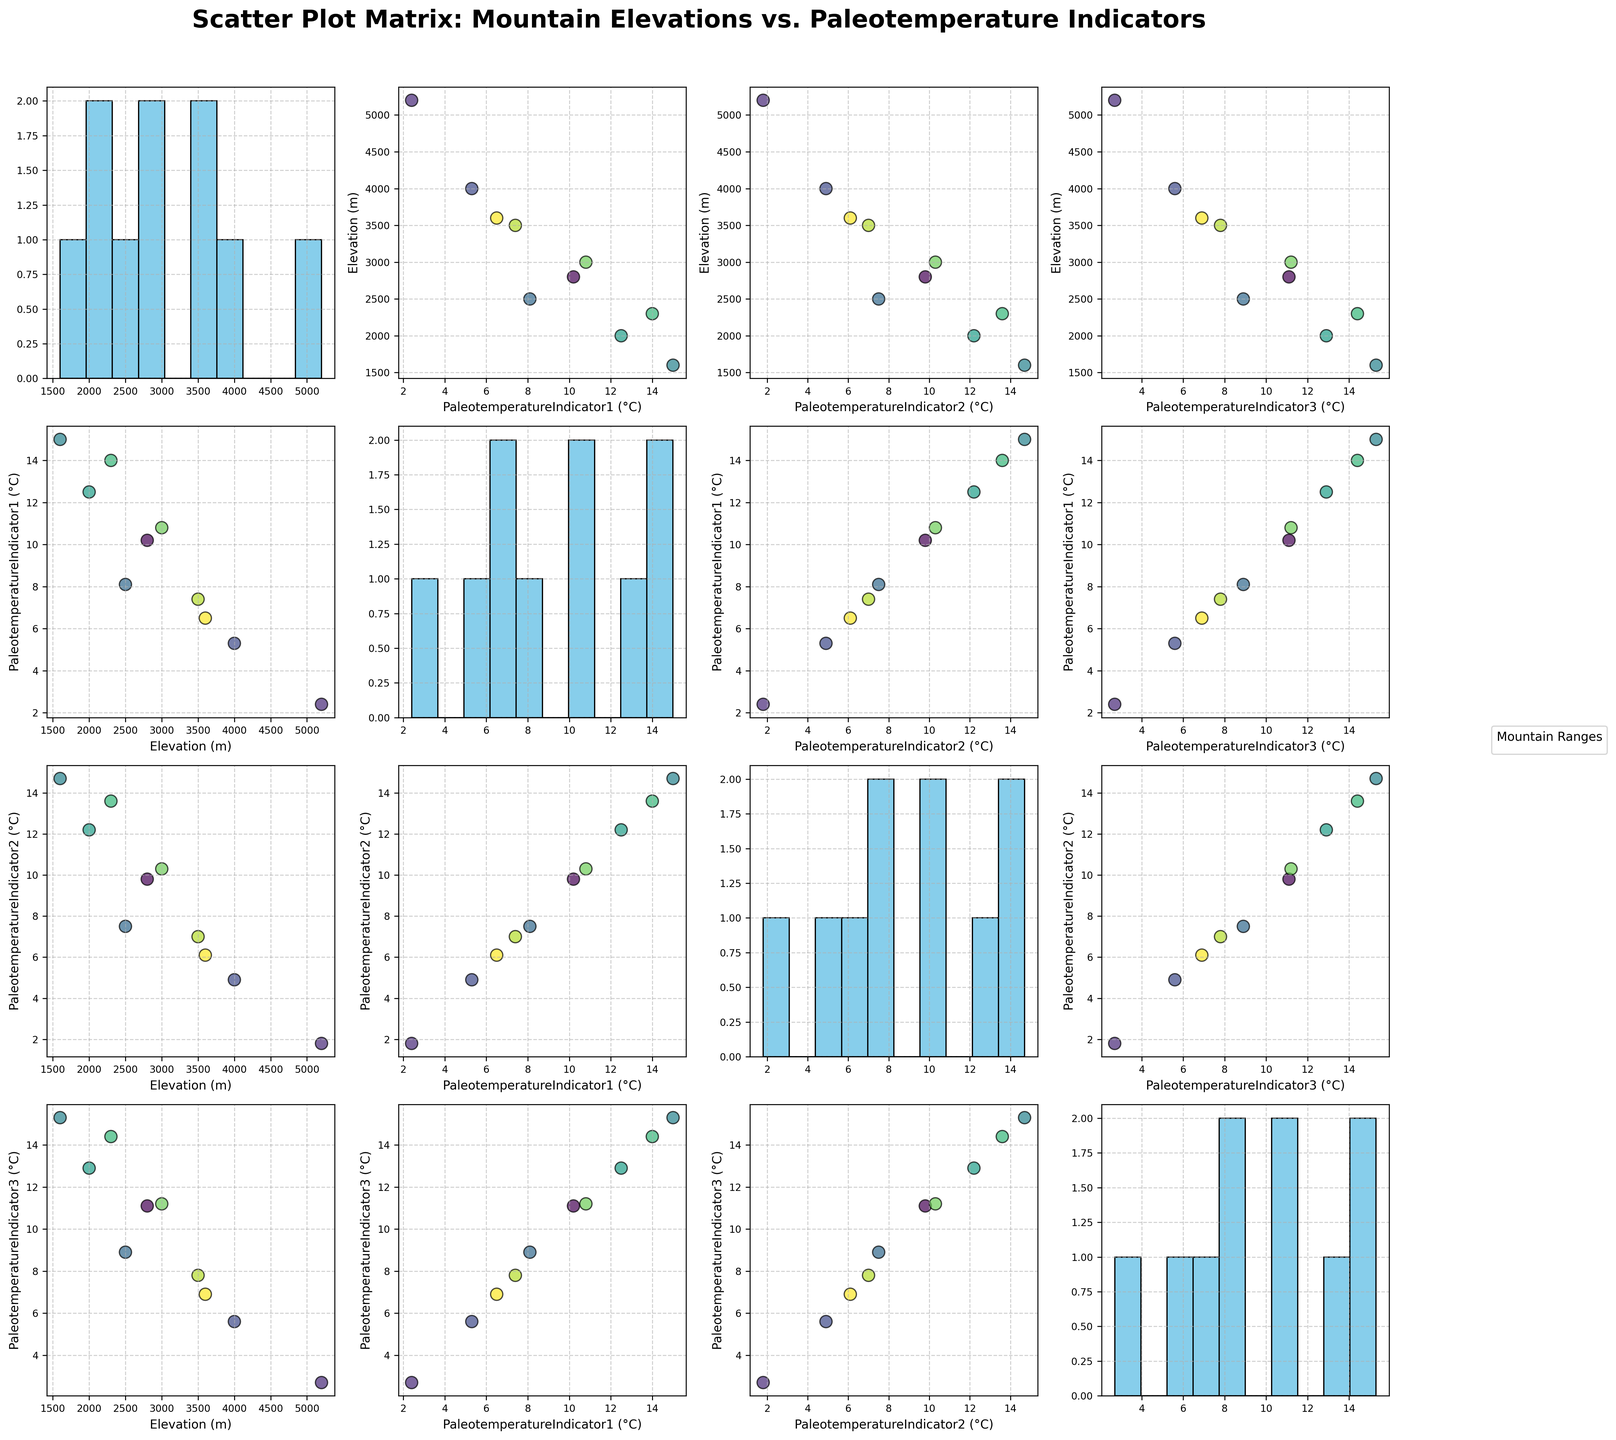What's the title of the scatter plot matrix? The title of the figure is located at the top-center and provides the overall description of the plot.
Answer: Scatter Plot Matrix: Mountain Elevations vs. Paleotemperature Indicators How many data points represent the Andes in the scatter plots? Each mountain range has a single data point in each scatter plot cell. There are 4 main variables (Elevation and 3 Paleotemperature Indicators), so each of the 4x4 scatter plot subplots features one point for Andes.
Answer: 1 Which Paleotemperature Indicator shows a stronger relationship with elevation - Indicator 1 or Indicator 2? By visually comparing the scatter plot subplots of 'Elevation (m)' with 'PaleotemperatureIndicator1 (°C)' and 'PaleotemperatureIndicator2 (°C)', we look for the plot with a clearer trend or pattern. Here, Indicator 1 shows a more noticeable trend.
Answer: Paleotemperature Indicator 1 Are any two Paleotemperature Indicators perfectly correlated? By observing the diagonal histogram intersection and their scatter plots, if points align or histograms match exactly, they indicate perfect correlation. None of the histograms or scatter plots indicate perfect alignment in their values.
Answer: No Which mountain range has the highest elevation, and what is its corresponding PaleotemperatureIndicator1 (°C)? Find the highest point in the 'Elevation (m)' histogram and trace its respective value in 'PaleotemperatureIndicator1 (°C)' subplot. The Himalayas have the highest elevation and their corresponding PaleotemperatureIndicator1 value is 2.4°C.
Answer: Himalayas, 2.4°C Does the Drakensberg mountain range show an above-average value in PaleotemperatureIndicator2 (°C)? Calculate the average of PaleotemperatureIndicator2 using the histogram. Then check if Drakensberg's data point in the PaleotemperatureIndicator2 individual subplot lies above this average.
Answer: Yes Which Paleotemperature Indicator has the widest range of values in the histograms? Compare the range of values in the histograms on the diagonal of the SPLOM. 'PaleotemperatureIndicator1 (°C)', 'PaleotemperatureIndicator2 (°C)', and 'PaleotemperatureIndicator3 (°C)' all have histograms. PaleotemperatureIndicator1 (°C) spans from 1.8°C to 15°C.
Answer: PaleotemperatureIndicator1 Is there an evident inverse relationship between any Paleotemperature Indicator and elevation? Inverse relationships appear as a downward trend in scatter plots. By visually comparing the scatter plots of elevation with each indicator, PaleotemperatureIndicator1 shows the clearest inverse relationship.
Answer: Yes, PaleotemperatureIndicator1 Which mountain has a higher PaleotemperatureIndicator3 (°C), Altai or Caucasus? Locate the points for Altai and Caucasus in the scatter plot subplot for 'PaleotemperatureIndicator3 (°C)'. The corresponding values indicate that Altai shows a higher value than Caucasus.
Answer: Altai 